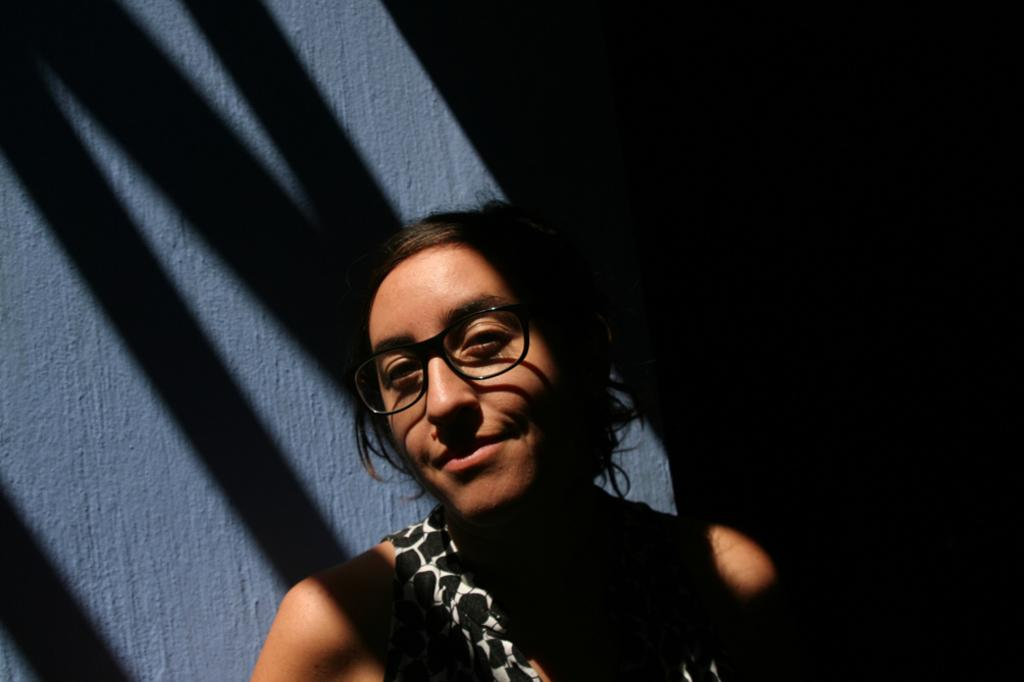What can be seen in the image? There is a person in the image. Can you describe the person's attire? The person is wearing a dress and spectacles. What is the background of the image? The person is standing near a grey color wall. How would you describe the lighting in the image? The image is taken in a dark environment. What type of food is the person eating in the image? There is no food present in the image, so it cannot be determined what the person might be eating. 